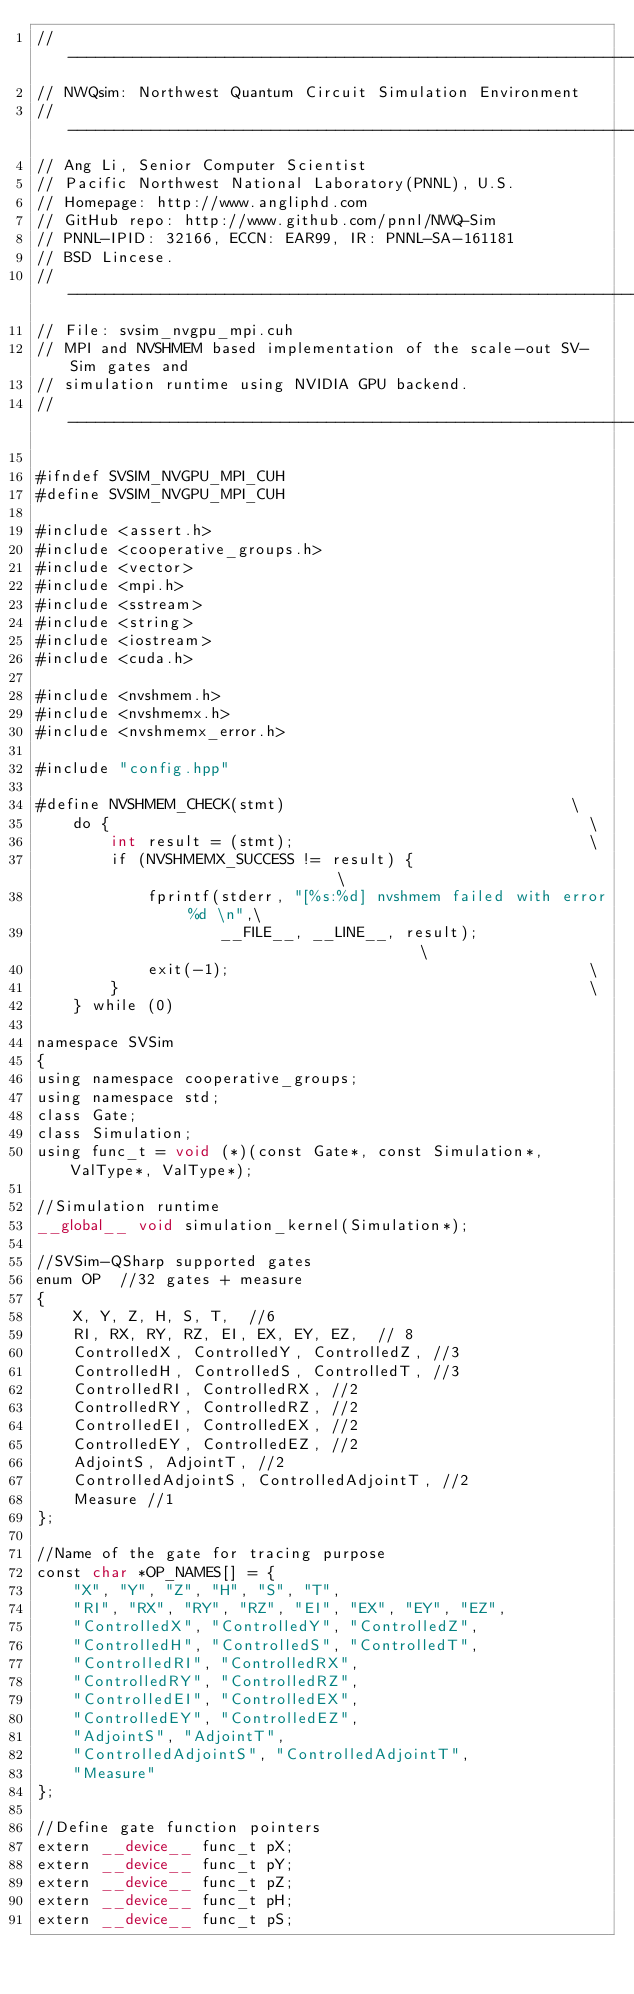Convert code to text. <code><loc_0><loc_0><loc_500><loc_500><_Cuda_>// ---------------------------------------------------------------------------
// NWQsim: Northwest Quantum Circuit Simulation Environment
// ---------------------------------------------------------------------------
// Ang Li, Senior Computer Scientist
// Pacific Northwest National Laboratory(PNNL), U.S.
// Homepage: http://www.angliphd.com
// GitHub repo: http://www.github.com/pnnl/NWQ-Sim
// PNNL-IPID: 32166, ECCN: EAR99, IR: PNNL-SA-161181
// BSD Lincese.
// ---------------------------------------------------------------------------
// File: svsim_nvgpu_mpi.cuh
// MPI and NVSHMEM based implementation of the scale-out SV-Sim gates and 
// simulation runtime using NVIDIA GPU backend.
// ---------------------------------------------------------------------------

#ifndef SVSIM_NVGPU_MPI_CUH
#define SVSIM_NVGPU_MPI_CUH

#include <assert.h>
#include <cooperative_groups.h>
#include <vector>
#include <mpi.h>
#include <sstream>
#include <string>
#include <iostream>
#include <cuda.h>

#include <nvshmem.h>
#include <nvshmemx.h>
#include <nvshmemx_error.h>

#include "config.hpp"

#define NVSHMEM_CHECK(stmt)                               \
    do {                                                    \
        int result = (stmt);                                \
        if (NVSHMEMX_SUCCESS != result) {                      \
            fprintf(stderr, "[%s:%d] nvshmem failed with error %d \n",\
                    __FILE__, __LINE__, result);                   \
            exit(-1);                                       \
        }                                                   \
    } while (0)

namespace SVSim
{
using namespace cooperative_groups;
using namespace std;
class Gate;
class Simulation;
using func_t = void (*)(const Gate*, const Simulation*, ValType*, ValType*);

//Simulation runtime
__global__ void simulation_kernel(Simulation*);

//SVSim-QSharp supported gates
enum OP  //32 gates + measure
{
    X, Y, Z, H, S, T,  //6
    RI, RX, RY, RZ, EI, EX, EY, EZ,  // 8
    ControlledX, ControlledY, ControlledZ, //3
    ControlledH, ControlledS, ControlledT, //3
    ControlledRI, ControlledRX, //2
    ControlledRY, ControlledRZ, //2
    ControlledEI, ControlledEX, //2
    ControlledEY, ControlledEZ, //2
    AdjointS, AdjointT, //2
    ControlledAdjointS, ControlledAdjointT, //2
    Measure //1
};

//Name of the gate for tracing purpose
const char *OP_NAMES[] = {
    "X", "Y", "Z", "H", "S", "T", 
    "RI", "RX", "RY", "RZ", "EI", "EX", "EY", "EZ", 
    "ControlledX", "ControlledY", "ControlledZ",
    "ControlledH", "ControlledS", "ControlledT",
    "ControlledRI", "ControlledRX", 
    "ControlledRY", "ControlledRZ", 
    "ControlledEI", "ControlledEX",
    "ControlledEY", "ControlledEZ", 
    "AdjointS", "AdjointT", 
    "ControlledAdjointS", "ControlledAdjointT", 
    "Measure"
};

//Define gate function pointers
extern __device__ func_t pX;
extern __device__ func_t pY;
extern __device__ func_t pZ;
extern __device__ func_t pH;
extern __device__ func_t pS;</code> 